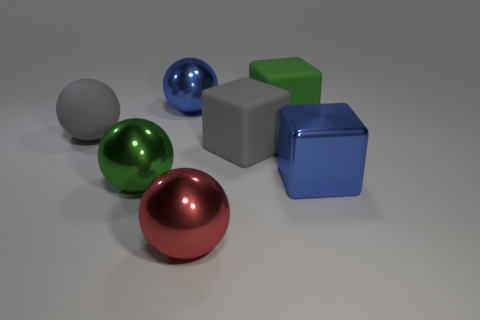Add 1 big green shiny objects. How many objects exist? 8 Subtract all large blue metal cubes. How many cubes are left? 2 Subtract all blue balls. How many balls are left? 3 Subtract all blocks. How many objects are left? 4 Subtract 0 purple cylinders. How many objects are left? 7 Subtract 3 blocks. How many blocks are left? 0 Subtract all red cubes. Subtract all yellow spheres. How many cubes are left? 3 Subtract all gray balls. Subtract all green cubes. How many objects are left? 5 Add 1 large gray objects. How many large gray objects are left? 3 Add 7 large matte spheres. How many large matte spheres exist? 8 